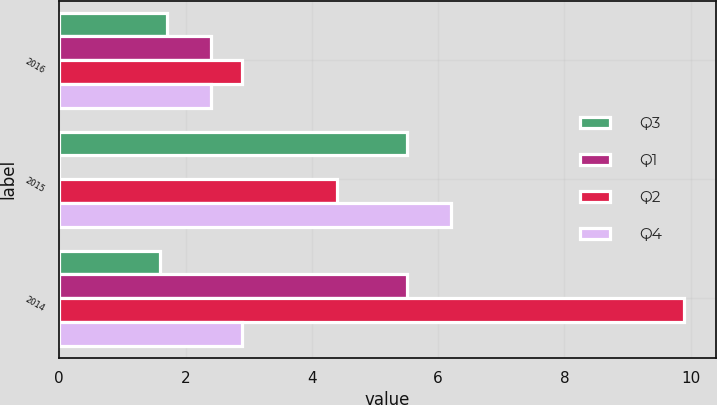<chart> <loc_0><loc_0><loc_500><loc_500><stacked_bar_chart><ecel><fcel>2016<fcel>2015<fcel>2014<nl><fcel>Q3<fcel>1.7<fcel>5.5<fcel>1.6<nl><fcel>Q1<fcel>2.4<fcel>0<fcel>5.5<nl><fcel>Q2<fcel>2.9<fcel>4.4<fcel>9.9<nl><fcel>Q4<fcel>2.4<fcel>6.2<fcel>2.9<nl></chart> 